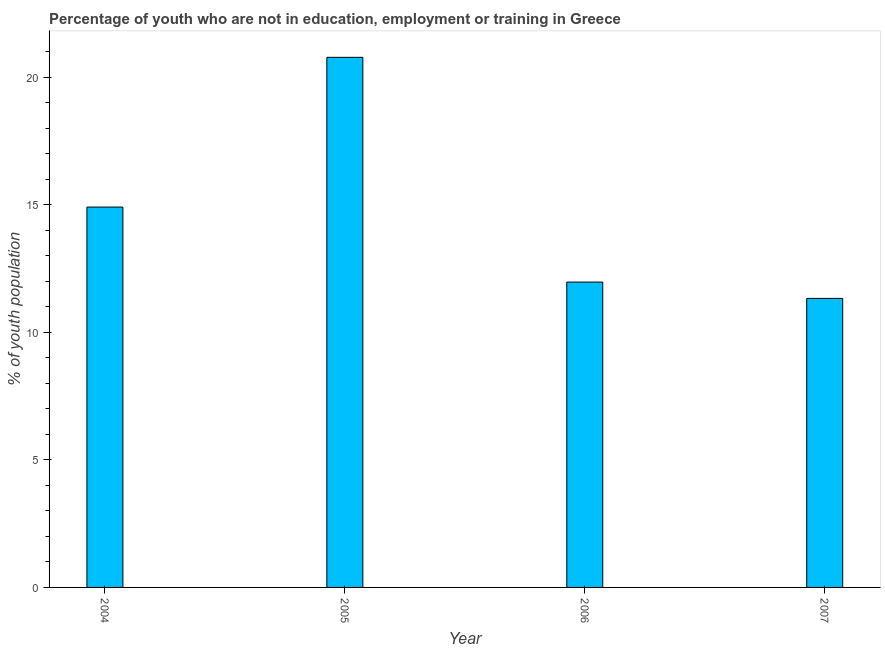Does the graph contain grids?
Your answer should be compact. No. What is the title of the graph?
Keep it short and to the point. Percentage of youth who are not in education, employment or training in Greece. What is the label or title of the Y-axis?
Make the answer very short. % of youth population. What is the unemployed youth population in 2006?
Your answer should be very brief. 11.97. Across all years, what is the maximum unemployed youth population?
Make the answer very short. 20.78. Across all years, what is the minimum unemployed youth population?
Ensure brevity in your answer.  11.33. What is the sum of the unemployed youth population?
Offer a very short reply. 58.99. What is the difference between the unemployed youth population in 2004 and 2007?
Ensure brevity in your answer.  3.58. What is the average unemployed youth population per year?
Make the answer very short. 14.75. What is the median unemployed youth population?
Offer a very short reply. 13.44. In how many years, is the unemployed youth population greater than 20 %?
Your response must be concise. 1. Do a majority of the years between 2004 and 2005 (inclusive) have unemployed youth population greater than 17 %?
Offer a very short reply. No. What is the ratio of the unemployed youth population in 2005 to that in 2006?
Your answer should be compact. 1.74. Is the unemployed youth population in 2004 less than that in 2007?
Your response must be concise. No. Is the difference between the unemployed youth population in 2004 and 2005 greater than the difference between any two years?
Your response must be concise. No. What is the difference between the highest and the second highest unemployed youth population?
Give a very brief answer. 5.87. Is the sum of the unemployed youth population in 2004 and 2007 greater than the maximum unemployed youth population across all years?
Keep it short and to the point. Yes. What is the difference between the highest and the lowest unemployed youth population?
Keep it short and to the point. 9.45. How many years are there in the graph?
Give a very brief answer. 4. Are the values on the major ticks of Y-axis written in scientific E-notation?
Provide a short and direct response. No. What is the % of youth population of 2004?
Provide a succinct answer. 14.91. What is the % of youth population in 2005?
Your answer should be compact. 20.78. What is the % of youth population in 2006?
Make the answer very short. 11.97. What is the % of youth population of 2007?
Keep it short and to the point. 11.33. What is the difference between the % of youth population in 2004 and 2005?
Your answer should be very brief. -5.87. What is the difference between the % of youth population in 2004 and 2006?
Provide a succinct answer. 2.94. What is the difference between the % of youth population in 2004 and 2007?
Your answer should be very brief. 3.58. What is the difference between the % of youth population in 2005 and 2006?
Provide a succinct answer. 8.81. What is the difference between the % of youth population in 2005 and 2007?
Give a very brief answer. 9.45. What is the difference between the % of youth population in 2006 and 2007?
Your response must be concise. 0.64. What is the ratio of the % of youth population in 2004 to that in 2005?
Your response must be concise. 0.72. What is the ratio of the % of youth population in 2004 to that in 2006?
Ensure brevity in your answer.  1.25. What is the ratio of the % of youth population in 2004 to that in 2007?
Give a very brief answer. 1.32. What is the ratio of the % of youth population in 2005 to that in 2006?
Your answer should be very brief. 1.74. What is the ratio of the % of youth population in 2005 to that in 2007?
Make the answer very short. 1.83. What is the ratio of the % of youth population in 2006 to that in 2007?
Provide a succinct answer. 1.06. 